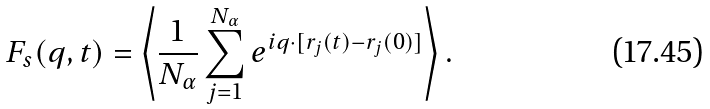Convert formula to latex. <formula><loc_0><loc_0><loc_500><loc_500>F _ { s } ( q , t ) = \left \langle \frac { 1 } { N _ { \alpha } } \sum _ { j = 1 } ^ { N _ { \alpha } } e ^ { i { q } \cdot [ { r } _ { j } ( t ) - { r } _ { j } ( 0 ) ] } \right \rangle .</formula> 